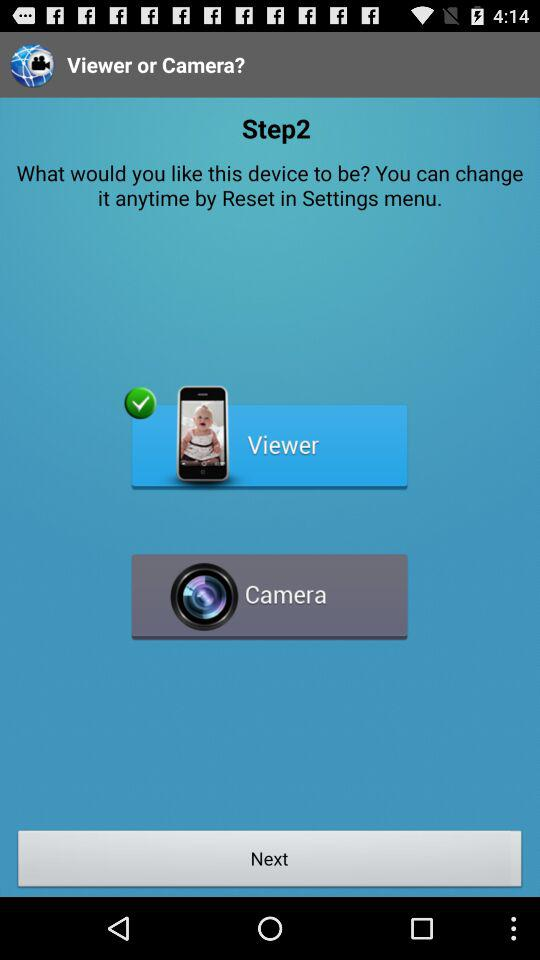Which step is currently shown? The currently shown step is 2. 